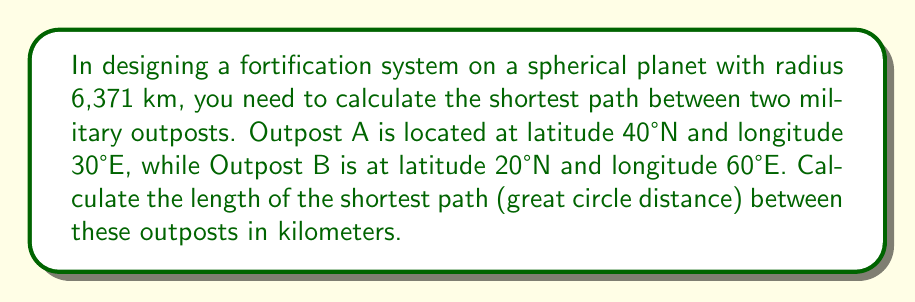Can you answer this question? To solve this problem, we'll use the spherical law of cosines formula for great circle distance. Here's the step-by-step solution:

1) Convert the latitudes and longitudes to radians:
   $\phi_1 = 40° \cdot \frac{\pi}{180°} = 0.6981$ rad
   $\lambda_1 = 30° \cdot \frac{\pi}{180°} = 0.5236$ rad
   $\phi_2 = 20° \cdot \frac{\pi}{180°} = 0.3491$ rad
   $\lambda_2 = 60° \cdot \frac{\pi}{180°} = 1.0472$ rad

2) Use the spherical law of cosines formula:
   $$\cos(c) = \sin(\phi_1)\sin(\phi_2) + \cos(\phi_1)\cos(\phi_2)\cos(\lambda_2 - \lambda_1)$$

   Where $c$ is the central angle between the points.

3) Plug in the values:
   $$\cos(c) = \sin(0.6981)\sin(0.3491) + \cos(0.6981)\cos(0.3491)\cos(1.0472 - 0.5236)$$

4) Calculate:
   $$\cos(c) = 0.9284$$

5) Take the inverse cosine (arccos) to find the central angle $c$:
   $$c = \arccos(0.9284) = 0.3840 \text{ radians}$$

6) Calculate the great circle distance $d$ using the formula:
   $$d = R \cdot c$$
   Where $R$ is the radius of the planet (6,371 km).

   $$d = 6371 \cdot 0.3840 = 2446.46 \text{ km}$$

Therefore, the shortest path between the two outposts is approximately 2,446.46 km.
Answer: 2,446.46 km 